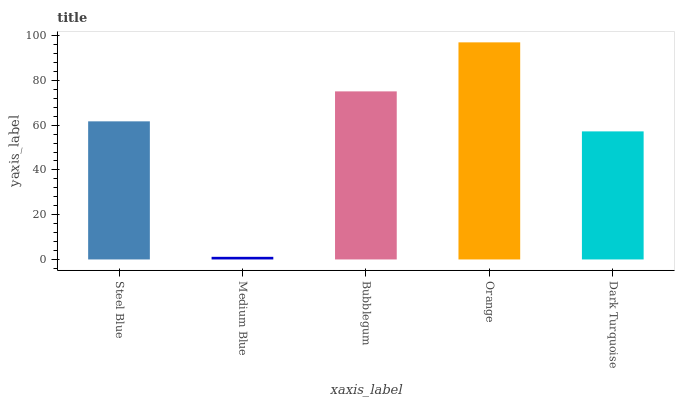Is Medium Blue the minimum?
Answer yes or no. Yes. Is Orange the maximum?
Answer yes or no. Yes. Is Bubblegum the minimum?
Answer yes or no. No. Is Bubblegum the maximum?
Answer yes or no. No. Is Bubblegum greater than Medium Blue?
Answer yes or no. Yes. Is Medium Blue less than Bubblegum?
Answer yes or no. Yes. Is Medium Blue greater than Bubblegum?
Answer yes or no. No. Is Bubblegum less than Medium Blue?
Answer yes or no. No. Is Steel Blue the high median?
Answer yes or no. Yes. Is Steel Blue the low median?
Answer yes or no. Yes. Is Medium Blue the high median?
Answer yes or no. No. Is Dark Turquoise the low median?
Answer yes or no. No. 